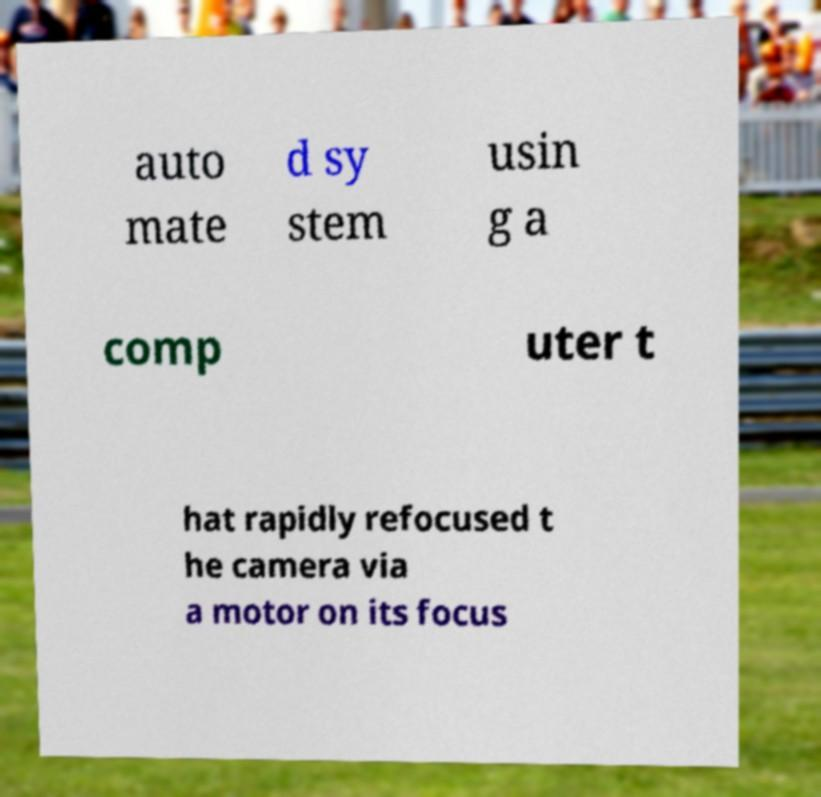There's text embedded in this image that I need extracted. Can you transcribe it verbatim? auto mate d sy stem usin g a comp uter t hat rapidly refocused t he camera via a motor on its focus 